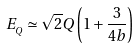<formula> <loc_0><loc_0><loc_500><loc_500>E _ { _ { Q } } \simeq \sqrt { 2 } Q \left ( 1 + { \frac { 3 } { 4 b } } \right )</formula> 